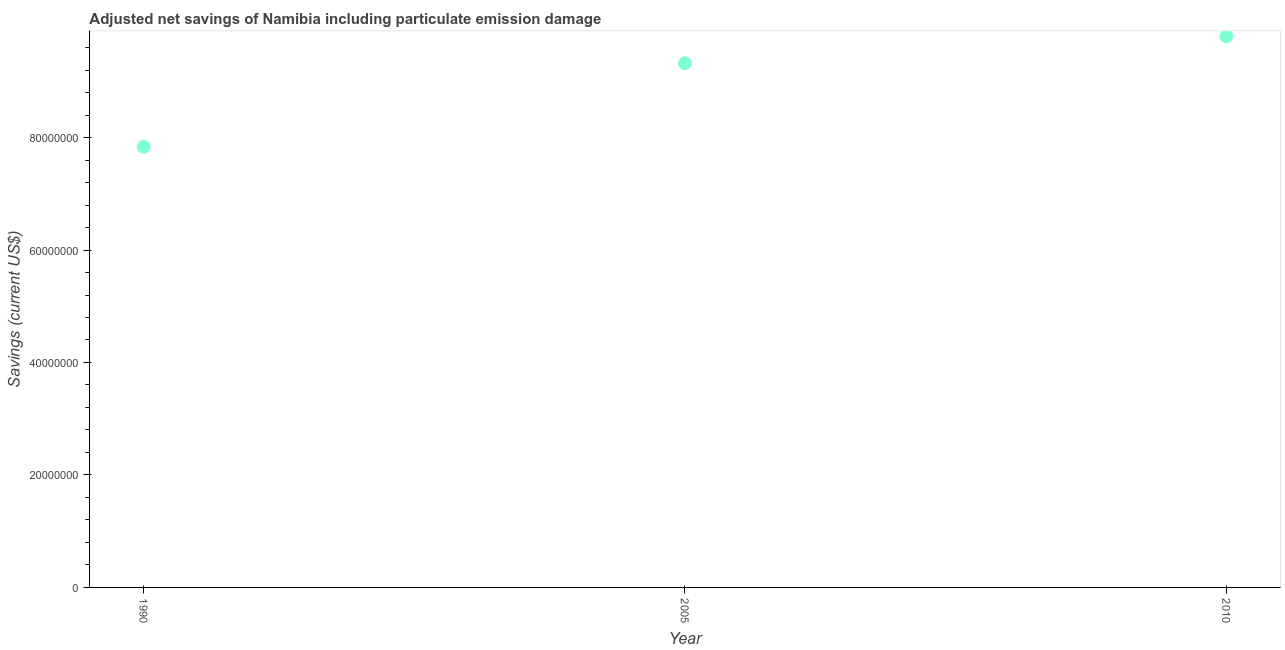What is the adjusted net savings in 2010?
Provide a succinct answer. 9.80e+07. Across all years, what is the maximum adjusted net savings?
Your answer should be very brief. 9.80e+07. Across all years, what is the minimum adjusted net savings?
Ensure brevity in your answer.  7.84e+07. In which year was the adjusted net savings maximum?
Your answer should be very brief. 2010. In which year was the adjusted net savings minimum?
Offer a very short reply. 1990. What is the sum of the adjusted net savings?
Keep it short and to the point. 2.70e+08. What is the difference between the adjusted net savings in 2005 and 2010?
Make the answer very short. -4.78e+06. What is the average adjusted net savings per year?
Your answer should be very brief. 8.99e+07. What is the median adjusted net savings?
Your answer should be compact. 9.32e+07. Do a majority of the years between 1990 and 2005 (inclusive) have adjusted net savings greater than 92000000 US$?
Offer a very short reply. No. What is the ratio of the adjusted net savings in 1990 to that in 2005?
Make the answer very short. 0.84. Is the difference between the adjusted net savings in 1990 and 2010 greater than the difference between any two years?
Provide a succinct answer. Yes. What is the difference between the highest and the second highest adjusted net savings?
Make the answer very short. 4.78e+06. What is the difference between the highest and the lowest adjusted net savings?
Give a very brief answer. 1.96e+07. In how many years, is the adjusted net savings greater than the average adjusted net savings taken over all years?
Make the answer very short. 2. Does the adjusted net savings monotonically increase over the years?
Keep it short and to the point. Yes. How many years are there in the graph?
Provide a short and direct response. 3. What is the difference between two consecutive major ticks on the Y-axis?
Your answer should be very brief. 2.00e+07. Are the values on the major ticks of Y-axis written in scientific E-notation?
Make the answer very short. No. What is the title of the graph?
Ensure brevity in your answer.  Adjusted net savings of Namibia including particulate emission damage. What is the label or title of the X-axis?
Your answer should be compact. Year. What is the label or title of the Y-axis?
Give a very brief answer. Savings (current US$). What is the Savings (current US$) in 1990?
Offer a very short reply. 7.84e+07. What is the Savings (current US$) in 2005?
Your answer should be compact. 9.32e+07. What is the Savings (current US$) in 2010?
Your answer should be very brief. 9.80e+07. What is the difference between the Savings (current US$) in 1990 and 2005?
Provide a succinct answer. -1.49e+07. What is the difference between the Savings (current US$) in 1990 and 2010?
Make the answer very short. -1.96e+07. What is the difference between the Savings (current US$) in 2005 and 2010?
Your answer should be compact. -4.78e+06. What is the ratio of the Savings (current US$) in 1990 to that in 2005?
Your response must be concise. 0.84. What is the ratio of the Savings (current US$) in 1990 to that in 2010?
Provide a short and direct response. 0.8. What is the ratio of the Savings (current US$) in 2005 to that in 2010?
Provide a short and direct response. 0.95. 